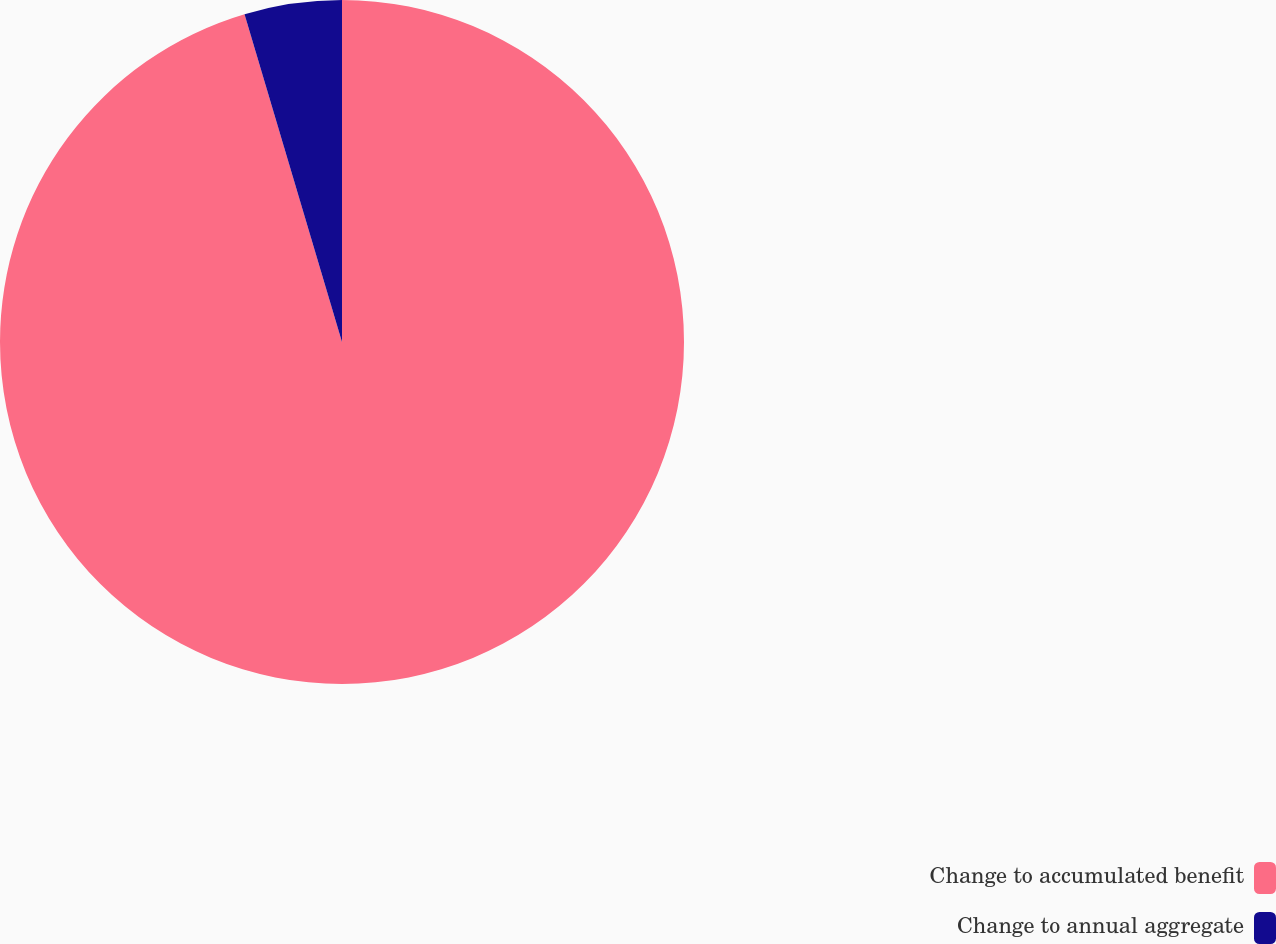Convert chart. <chart><loc_0><loc_0><loc_500><loc_500><pie_chart><fcel>Change to accumulated benefit<fcel>Change to annual aggregate<nl><fcel>95.4%<fcel>4.6%<nl></chart> 